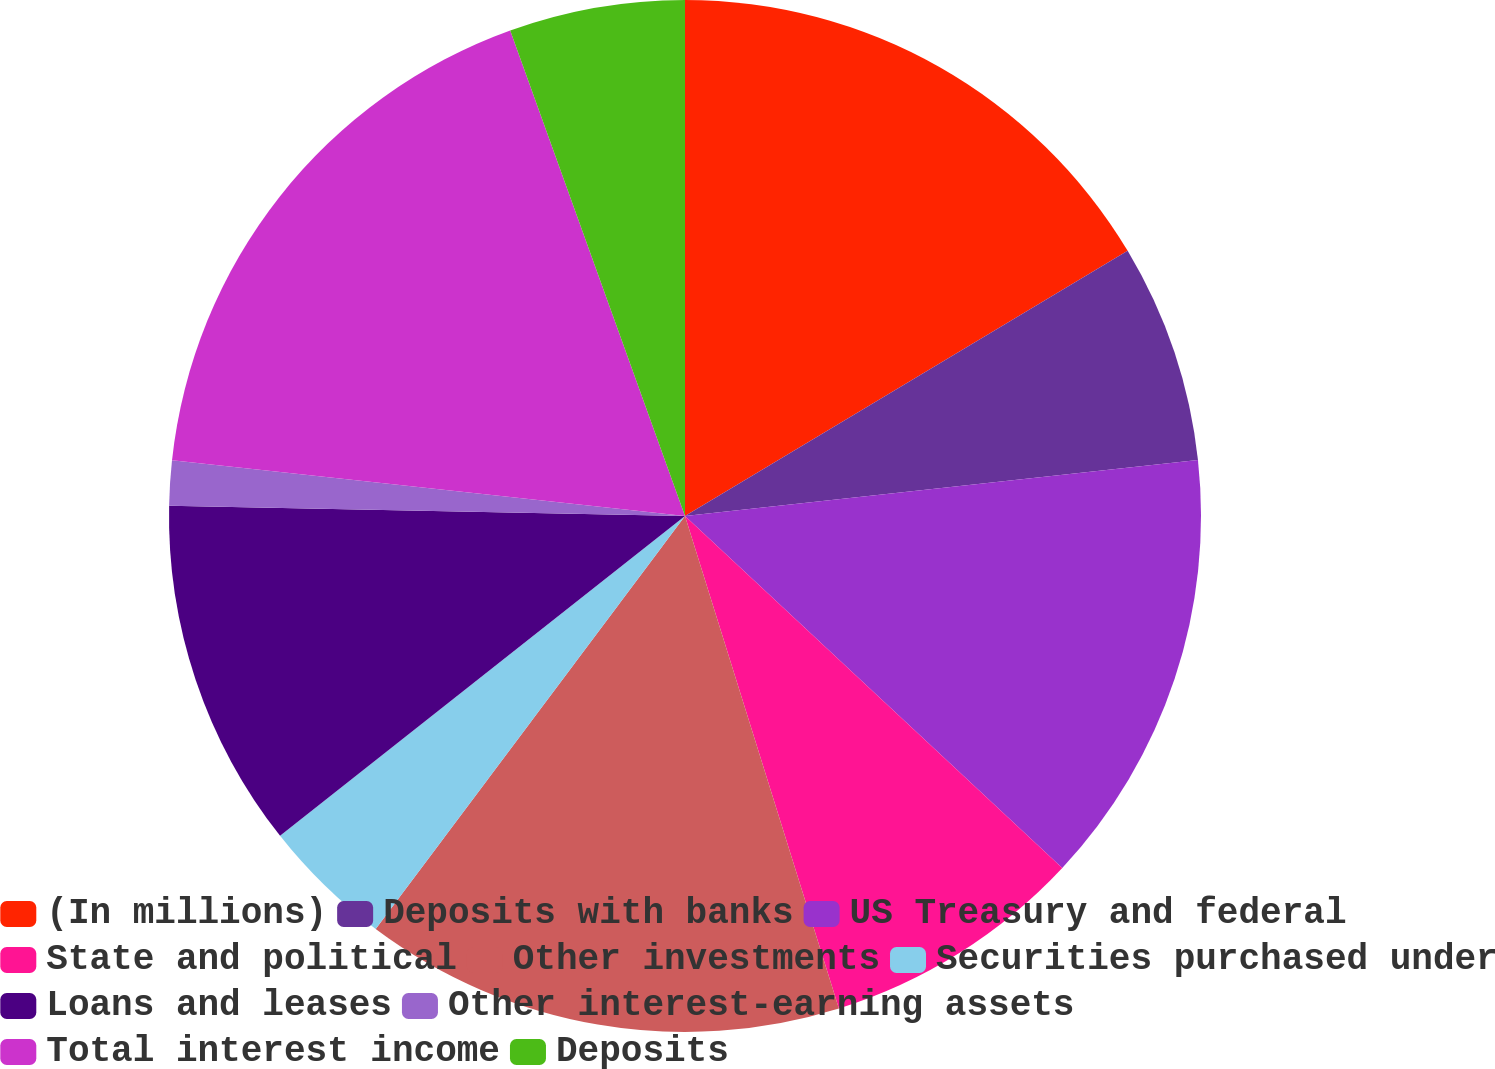Convert chart. <chart><loc_0><loc_0><loc_500><loc_500><pie_chart><fcel>(In millions)<fcel>Deposits with banks<fcel>US Treasury and federal<fcel>State and political<fcel>Other investments<fcel>Securities purchased under<fcel>Loans and leases<fcel>Other interest-earning assets<fcel>Total interest income<fcel>Deposits<nl><fcel>16.41%<fcel>6.86%<fcel>13.68%<fcel>8.23%<fcel>15.05%<fcel>4.13%<fcel>10.96%<fcel>1.4%<fcel>17.78%<fcel>5.5%<nl></chart> 